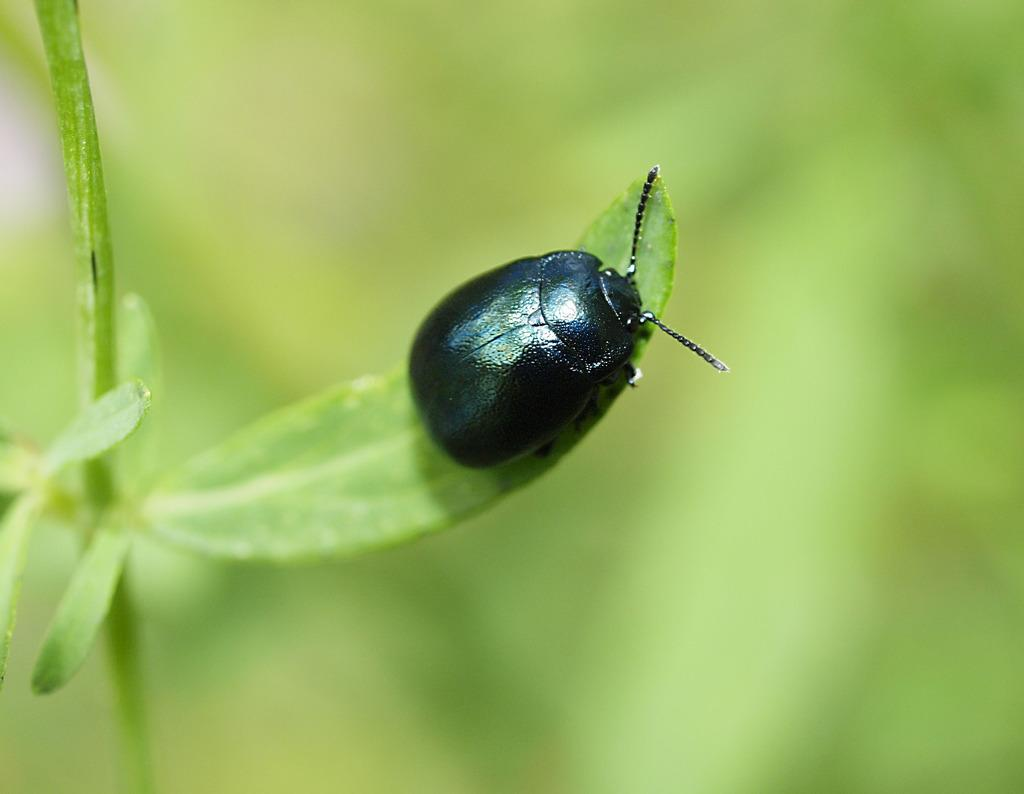What type of insect is in the image? There is a black color insect in the image. Where is the insect located? The insect is on a leaf of a plant. Can you describe the background of the image? The background of the image is blurred. What type of thread is the boy using to climb the top in the image? There is no boy, thread, or top present in the image. 